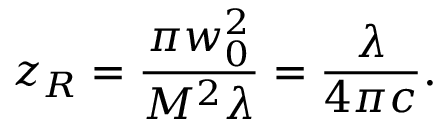Convert formula to latex. <formula><loc_0><loc_0><loc_500><loc_500>z _ { R } = \frac { \pi w _ { 0 } ^ { 2 } } { M ^ { 2 } \lambda } = \frac { \lambda } { 4 \pi c } .</formula> 